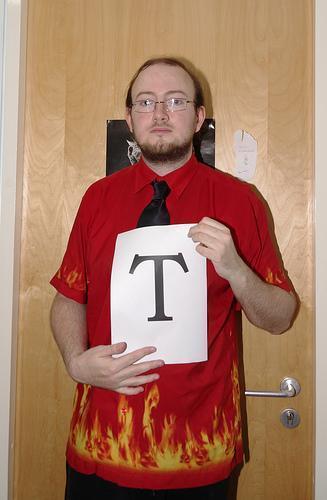How many people are in the photo?
Give a very brief answer. 1. 